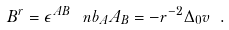Convert formula to latex. <formula><loc_0><loc_0><loc_500><loc_500>B ^ { r } = \epsilon ^ { A B } \, \ n b _ { A } A _ { B } = - r ^ { - 2 } \Delta _ { 0 } v \ .</formula> 